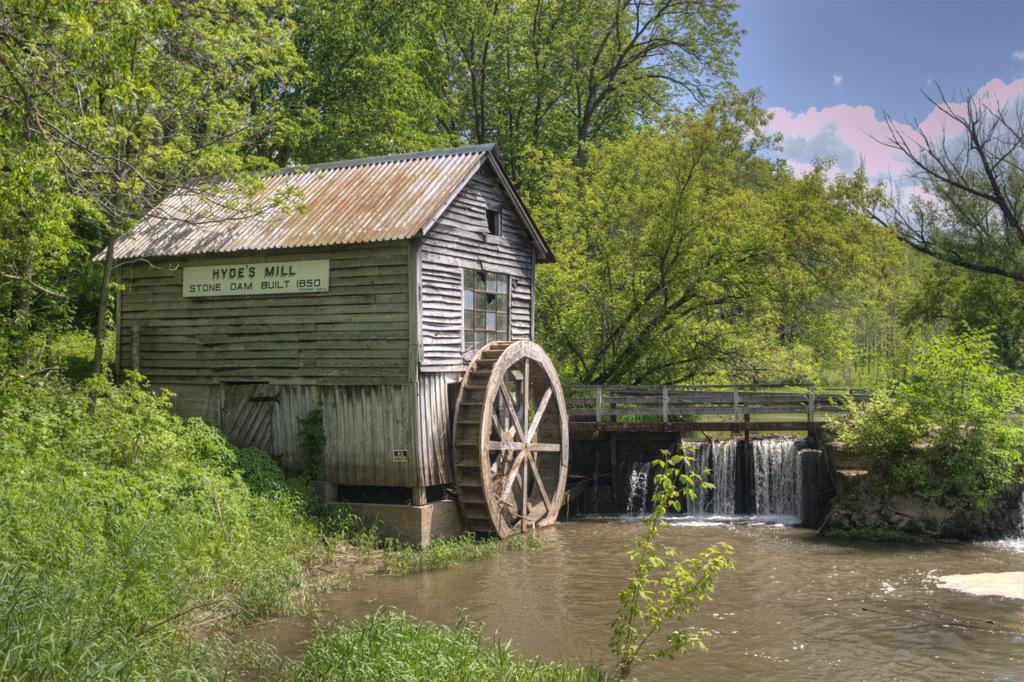Could you give a brief overview of what you see in this image? At the bottom of the image there is water. On the left side of the image there are small plants. And also there is a house with roofs, walls, glass windows and there is a board with some text on it. And also there is an object which looks like a wheel. And also there is a bridge with fencing and there is flow of water. In the background there are many trees and also there is sky with clouds.  